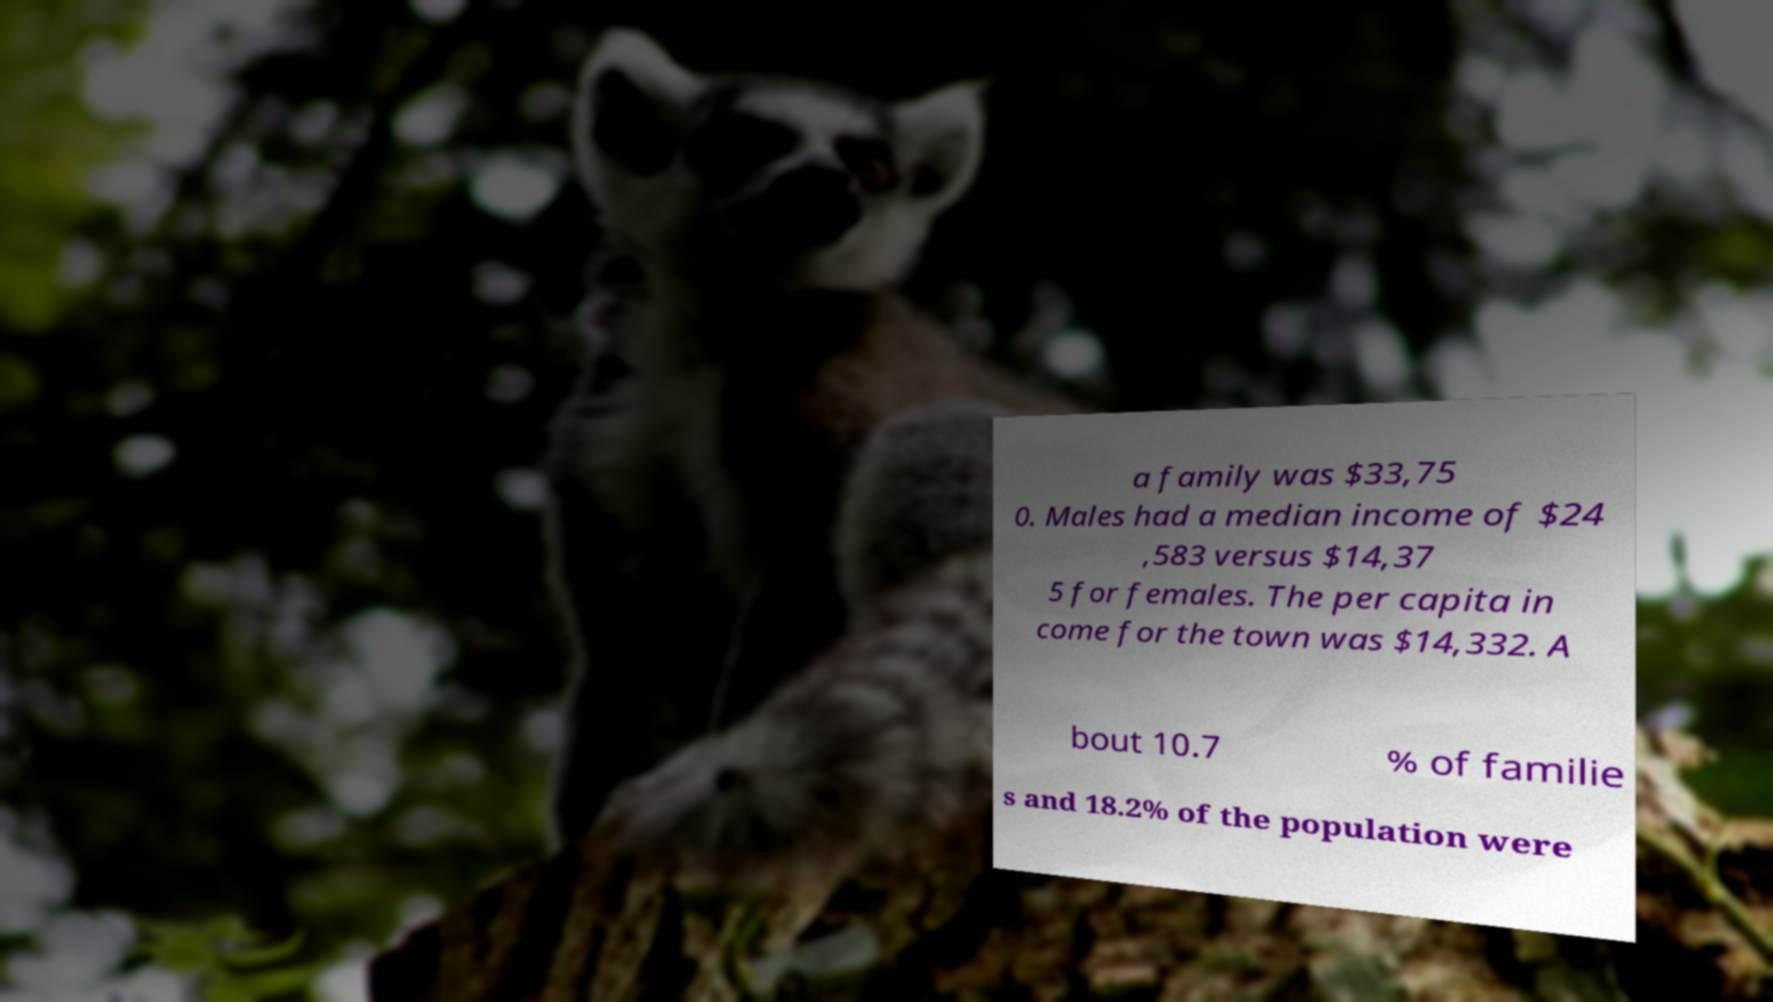Please read and relay the text visible in this image. What does it say? a family was $33,75 0. Males had a median income of $24 ,583 versus $14,37 5 for females. The per capita in come for the town was $14,332. A bout 10.7 % of familie s and 18.2% of the population were 